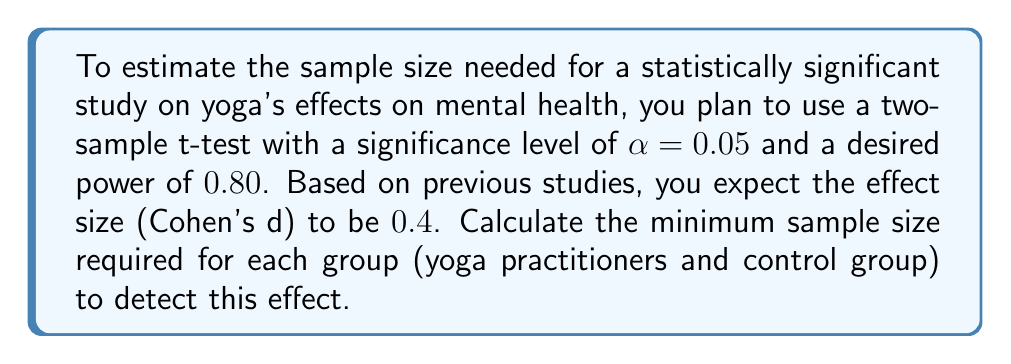Teach me how to tackle this problem. To calculate the sample size, we'll use the formula for a two-sample t-test:

$$n = \frac{2(z_{\alpha/2} + z_{\beta})^2}{\delta^2}$$

Where:
- $n$ is the sample size per group
- $z_{\alpha/2}$ is the critical value for a two-tailed test at significance level $\alpha$
- $z_{\beta}$ is the critical value for the desired power $(1-\beta)$
- $\delta$ is the effect size (Cohen's d)

Step 1: Determine the critical values
- For $\alpha = 0.05$, $z_{\alpha/2} = 1.96$
- For power $= 0.80$, $\beta = 0.20$, so $z_{\beta} = 0.84$

Step 2: Use the given effect size
$\delta = 0.4$

Step 3: Apply the formula
$$n = \frac{2(1.96 + 0.84)^2}{(0.4)^2}$$

Step 4: Calculate
$$n = \frac{2(2.80)^2}{0.16} = \frac{15.68}{0.16} = 98$$

Step 5: Round up to the nearest whole number
$n = 99$

Therefore, you need a minimum of 99 participants in each group (yoga practitioners and control group) for a total of 198 participants in the study.
Answer: 99 participants per group 